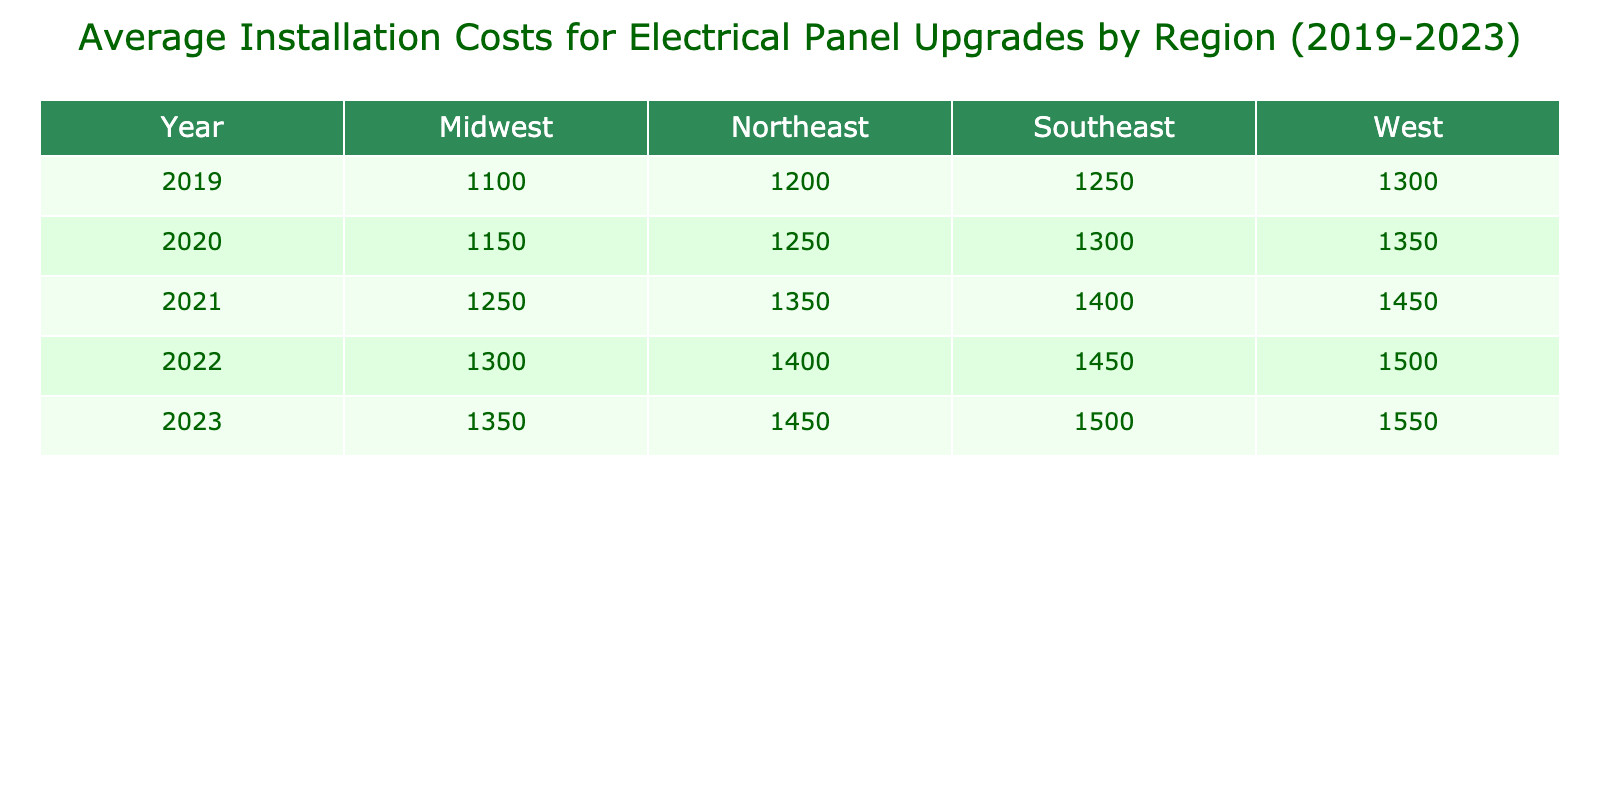What was the average installation cost for electrical panel upgrades in 2021? From the table, look at the row for the year 2021 in the "Average Installation Cost ($)" column. The value listed is 1350.
Answer: 1350 Which region had the highest average installation cost in 2022? Inspect the 2022 row for every region and compare the values. The West region has 1500, which is higher than the other regions: Northeast (1400), Midwest (1300), Southeast (1450).
Answer: West In which year did the Southeast region see the lowest average installation cost? Check the Southeast column for each year and find the minimum value. The lowest value is 1250 in 2019.
Answer: 2019 What is the total average installation cost across all regions for the year 2023? Sum the average installation costs for each region in 2023: 1450 (Northeast) + 1350 (Midwest) + 1550 (West) + 1500 (Southeast) = 5850.
Answer: 5850 Is the average installation cost in the Midwest greater than that in the Northeast in 2021? Compare the values for 2021: Midwest (1250) and Northeast (1350). Since 1250 is not greater than 1350, the answer is no.
Answer: No What was the trend in average installation costs from 2019 to 2023 for the West region? Evaluate the West column for each year: 1300, 1350, 1450, 1500, 1550. The costs consistently increased each year from 2019 to 2023.
Answer: Increased every year What was the average installation cost difference between high-end and low-end panel upgrades in the Northeast region for 2023? Find the values for high-end and low-end panel upgrades in 2023 for the Northeast: high-end (1800) and low-end (1000). The difference is 1800 - 1000 = 800.
Answer: 800 Did the average installation cost increase from 2020 to 2021 in the Midwest region? Examine the Midwest values: 1150 in 2020 and 1250 in 2021. Since 1250 is greater than 1150, it indeed increased.
Answer: Yes What was the average installation cost for high-end panel upgrades in the West region over the years 2019 to 2023? Extract the values from the West region for high-end: 1600 (2019), 1650 (2020), 1750 (2021), 1800 (2022), 1850 (2023). Add them and divide by the number of years (5): (1600 + 1650 + 1750 + 1800 + 1850) / 5 = 1730.
Answer: 1730 